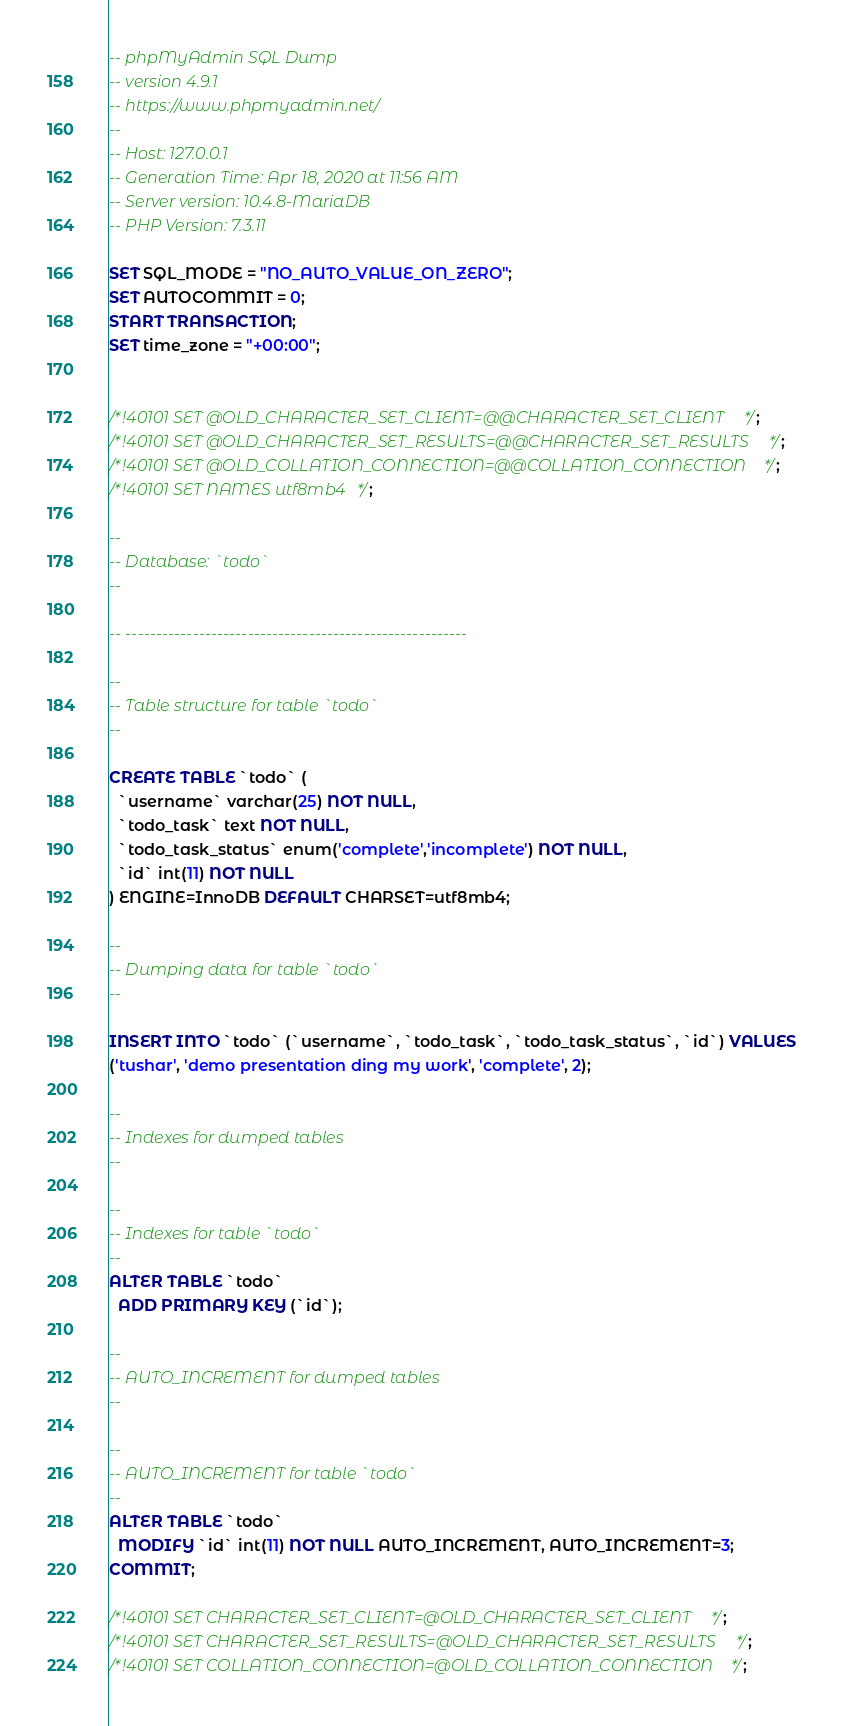<code> <loc_0><loc_0><loc_500><loc_500><_SQL_>-- phpMyAdmin SQL Dump
-- version 4.9.1
-- https://www.phpmyadmin.net/
--
-- Host: 127.0.0.1
-- Generation Time: Apr 18, 2020 at 11:56 AM
-- Server version: 10.4.8-MariaDB
-- PHP Version: 7.3.11

SET SQL_MODE = "NO_AUTO_VALUE_ON_ZERO";
SET AUTOCOMMIT = 0;
START TRANSACTION;
SET time_zone = "+00:00";


/*!40101 SET @OLD_CHARACTER_SET_CLIENT=@@CHARACTER_SET_CLIENT */;
/*!40101 SET @OLD_CHARACTER_SET_RESULTS=@@CHARACTER_SET_RESULTS */;
/*!40101 SET @OLD_COLLATION_CONNECTION=@@COLLATION_CONNECTION */;
/*!40101 SET NAMES utf8mb4 */;

--
-- Database: `todo`
--

-- --------------------------------------------------------

--
-- Table structure for table `todo`
--

CREATE TABLE `todo` (
  `username` varchar(25) NOT NULL,
  `todo_task` text NOT NULL,
  `todo_task_status` enum('complete','incomplete') NOT NULL,
  `id` int(11) NOT NULL
) ENGINE=InnoDB DEFAULT CHARSET=utf8mb4;

--
-- Dumping data for table `todo`
--

INSERT INTO `todo` (`username`, `todo_task`, `todo_task_status`, `id`) VALUES
('tushar', 'demo presentation ding my work', 'complete', 2);

--
-- Indexes for dumped tables
--

--
-- Indexes for table `todo`
--
ALTER TABLE `todo`
  ADD PRIMARY KEY (`id`);

--
-- AUTO_INCREMENT for dumped tables
--

--
-- AUTO_INCREMENT for table `todo`
--
ALTER TABLE `todo`
  MODIFY `id` int(11) NOT NULL AUTO_INCREMENT, AUTO_INCREMENT=3;
COMMIT;

/*!40101 SET CHARACTER_SET_CLIENT=@OLD_CHARACTER_SET_CLIENT */;
/*!40101 SET CHARACTER_SET_RESULTS=@OLD_CHARACTER_SET_RESULTS */;
/*!40101 SET COLLATION_CONNECTION=@OLD_COLLATION_CONNECTION */;
</code> 